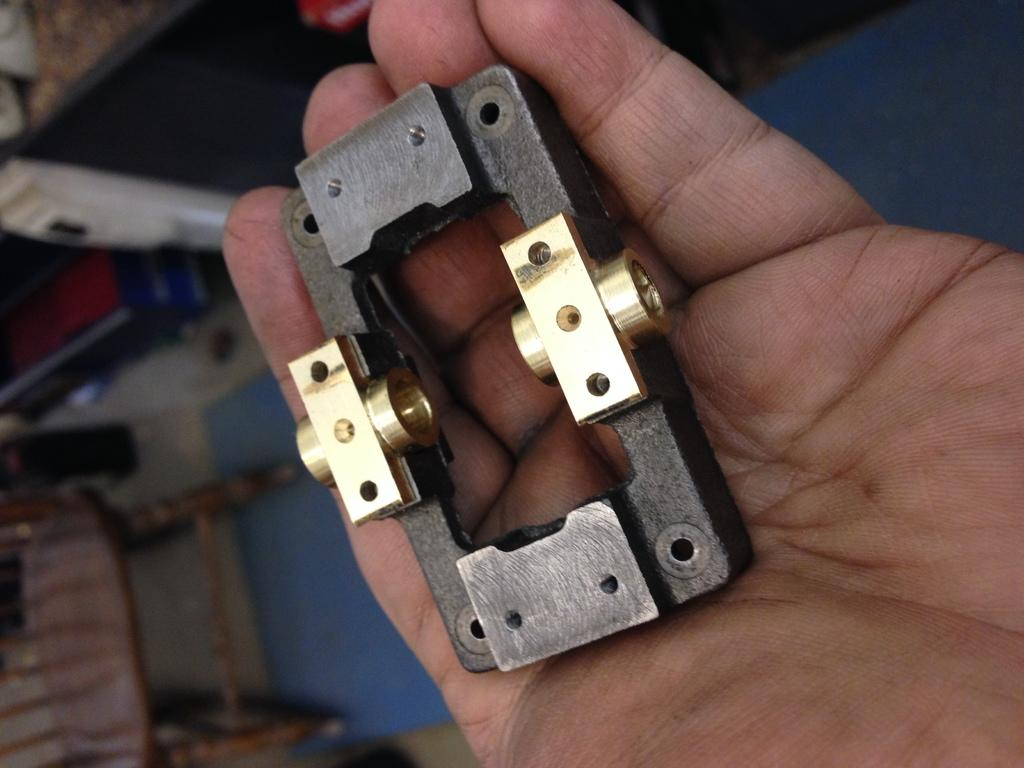What is on the person's hand in the image? There is an object on the hand of a person in the image. Can you describe the setting in the background of the image? There is a chair placed on the ground in the background of the image. What type of paste is being applied to the chair in the image? There is no paste or any indication of applying anything to the chair in the image. 